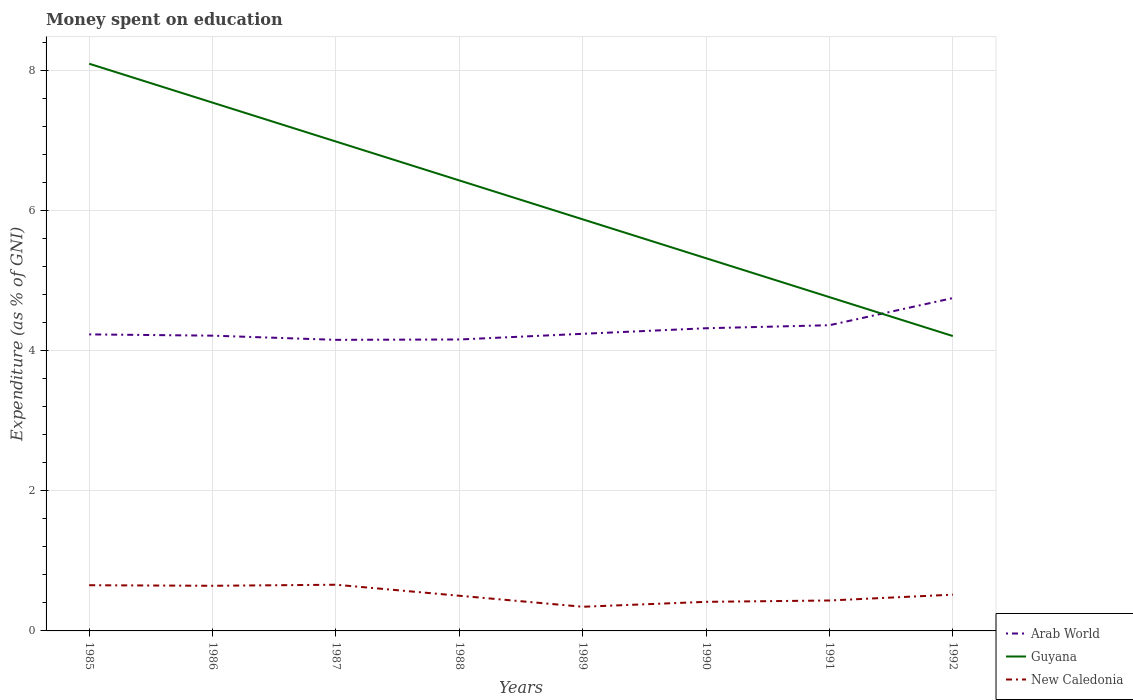How many different coloured lines are there?
Make the answer very short. 3. Is the number of lines equal to the number of legend labels?
Provide a succinct answer. Yes. Across all years, what is the maximum amount of money spent on education in New Caledonia?
Your answer should be compact. 0.35. What is the total amount of money spent on education in Arab World in the graph?
Make the answer very short. -0.08. What is the difference between the highest and the second highest amount of money spent on education in Arab World?
Your answer should be compact. 0.6. How many lines are there?
Your answer should be compact. 3. What is the difference between two consecutive major ticks on the Y-axis?
Your response must be concise. 2. How many legend labels are there?
Keep it short and to the point. 3. What is the title of the graph?
Keep it short and to the point. Money spent on education. What is the label or title of the Y-axis?
Your response must be concise. Expenditure (as % of GNI). What is the Expenditure (as % of GNI) in Arab World in 1985?
Your response must be concise. 4.23. What is the Expenditure (as % of GNI) of New Caledonia in 1985?
Offer a very short reply. 0.65. What is the Expenditure (as % of GNI) in Arab World in 1986?
Provide a short and direct response. 4.22. What is the Expenditure (as % of GNI) of Guyana in 1986?
Make the answer very short. 7.54. What is the Expenditure (as % of GNI) of New Caledonia in 1986?
Give a very brief answer. 0.64. What is the Expenditure (as % of GNI) of Arab World in 1987?
Offer a very short reply. 4.16. What is the Expenditure (as % of GNI) in Guyana in 1987?
Give a very brief answer. 6.99. What is the Expenditure (as % of GNI) of New Caledonia in 1987?
Give a very brief answer. 0.66. What is the Expenditure (as % of GNI) in Arab World in 1988?
Give a very brief answer. 4.16. What is the Expenditure (as % of GNI) in Guyana in 1988?
Offer a terse response. 6.43. What is the Expenditure (as % of GNI) of New Caledonia in 1988?
Provide a succinct answer. 0.5. What is the Expenditure (as % of GNI) of Arab World in 1989?
Provide a short and direct response. 4.24. What is the Expenditure (as % of GNI) in Guyana in 1989?
Keep it short and to the point. 5.88. What is the Expenditure (as % of GNI) of New Caledonia in 1989?
Give a very brief answer. 0.35. What is the Expenditure (as % of GNI) in Arab World in 1990?
Provide a short and direct response. 4.32. What is the Expenditure (as % of GNI) in Guyana in 1990?
Your answer should be compact. 5.32. What is the Expenditure (as % of GNI) in New Caledonia in 1990?
Provide a short and direct response. 0.42. What is the Expenditure (as % of GNI) of Arab World in 1991?
Keep it short and to the point. 4.37. What is the Expenditure (as % of GNI) in Guyana in 1991?
Your answer should be compact. 4.77. What is the Expenditure (as % of GNI) in New Caledonia in 1991?
Make the answer very short. 0.43. What is the Expenditure (as % of GNI) in Arab World in 1992?
Keep it short and to the point. 4.75. What is the Expenditure (as % of GNI) of Guyana in 1992?
Offer a terse response. 4.21. What is the Expenditure (as % of GNI) in New Caledonia in 1992?
Provide a succinct answer. 0.52. Across all years, what is the maximum Expenditure (as % of GNI) of Arab World?
Provide a short and direct response. 4.75. Across all years, what is the maximum Expenditure (as % of GNI) in Guyana?
Offer a very short reply. 8.1. Across all years, what is the maximum Expenditure (as % of GNI) of New Caledonia?
Provide a succinct answer. 0.66. Across all years, what is the minimum Expenditure (as % of GNI) of Arab World?
Make the answer very short. 4.16. Across all years, what is the minimum Expenditure (as % of GNI) in Guyana?
Your answer should be very brief. 4.21. Across all years, what is the minimum Expenditure (as % of GNI) in New Caledonia?
Keep it short and to the point. 0.35. What is the total Expenditure (as % of GNI) in Arab World in the graph?
Provide a short and direct response. 34.45. What is the total Expenditure (as % of GNI) of Guyana in the graph?
Your answer should be compact. 49.24. What is the total Expenditure (as % of GNI) of New Caledonia in the graph?
Provide a short and direct response. 4.17. What is the difference between the Expenditure (as % of GNI) of Arab World in 1985 and that in 1986?
Your response must be concise. 0.02. What is the difference between the Expenditure (as % of GNI) in Guyana in 1985 and that in 1986?
Provide a succinct answer. 0.56. What is the difference between the Expenditure (as % of GNI) of New Caledonia in 1985 and that in 1986?
Provide a short and direct response. 0.01. What is the difference between the Expenditure (as % of GNI) in Arab World in 1985 and that in 1987?
Your answer should be compact. 0.08. What is the difference between the Expenditure (as % of GNI) in New Caledonia in 1985 and that in 1987?
Provide a succinct answer. -0.01. What is the difference between the Expenditure (as % of GNI) in Arab World in 1985 and that in 1988?
Offer a very short reply. 0.07. What is the difference between the Expenditure (as % of GNI) in Guyana in 1985 and that in 1988?
Give a very brief answer. 1.67. What is the difference between the Expenditure (as % of GNI) in New Caledonia in 1985 and that in 1988?
Your answer should be compact. 0.15. What is the difference between the Expenditure (as % of GNI) in Arab World in 1985 and that in 1989?
Your response must be concise. -0.01. What is the difference between the Expenditure (as % of GNI) in Guyana in 1985 and that in 1989?
Offer a terse response. 2.22. What is the difference between the Expenditure (as % of GNI) of New Caledonia in 1985 and that in 1989?
Offer a very short reply. 0.31. What is the difference between the Expenditure (as % of GNI) in Arab World in 1985 and that in 1990?
Keep it short and to the point. -0.09. What is the difference between the Expenditure (as % of GNI) in Guyana in 1985 and that in 1990?
Your answer should be compact. 2.78. What is the difference between the Expenditure (as % of GNI) in New Caledonia in 1985 and that in 1990?
Provide a succinct answer. 0.24. What is the difference between the Expenditure (as % of GNI) in Arab World in 1985 and that in 1991?
Offer a terse response. -0.13. What is the difference between the Expenditure (as % of GNI) of Guyana in 1985 and that in 1991?
Keep it short and to the point. 3.33. What is the difference between the Expenditure (as % of GNI) of New Caledonia in 1985 and that in 1991?
Offer a terse response. 0.22. What is the difference between the Expenditure (as % of GNI) in Arab World in 1985 and that in 1992?
Your answer should be very brief. -0.52. What is the difference between the Expenditure (as % of GNI) in Guyana in 1985 and that in 1992?
Your answer should be very brief. 3.89. What is the difference between the Expenditure (as % of GNI) of New Caledonia in 1985 and that in 1992?
Provide a short and direct response. 0.13. What is the difference between the Expenditure (as % of GNI) of Arab World in 1986 and that in 1987?
Your answer should be compact. 0.06. What is the difference between the Expenditure (as % of GNI) in Guyana in 1986 and that in 1987?
Your response must be concise. 0.56. What is the difference between the Expenditure (as % of GNI) in New Caledonia in 1986 and that in 1987?
Offer a terse response. -0.01. What is the difference between the Expenditure (as % of GNI) in Arab World in 1986 and that in 1988?
Offer a very short reply. 0.05. What is the difference between the Expenditure (as % of GNI) in Guyana in 1986 and that in 1988?
Keep it short and to the point. 1.11. What is the difference between the Expenditure (as % of GNI) of New Caledonia in 1986 and that in 1988?
Give a very brief answer. 0.14. What is the difference between the Expenditure (as % of GNI) in Arab World in 1986 and that in 1989?
Keep it short and to the point. -0.03. What is the difference between the Expenditure (as % of GNI) of New Caledonia in 1986 and that in 1989?
Ensure brevity in your answer.  0.3. What is the difference between the Expenditure (as % of GNI) of Arab World in 1986 and that in 1990?
Make the answer very short. -0.11. What is the difference between the Expenditure (as % of GNI) of Guyana in 1986 and that in 1990?
Your answer should be very brief. 2.22. What is the difference between the Expenditure (as % of GNI) in New Caledonia in 1986 and that in 1990?
Your response must be concise. 0.23. What is the difference between the Expenditure (as % of GNI) in Arab World in 1986 and that in 1991?
Make the answer very short. -0.15. What is the difference between the Expenditure (as % of GNI) in Guyana in 1986 and that in 1991?
Offer a very short reply. 2.78. What is the difference between the Expenditure (as % of GNI) in New Caledonia in 1986 and that in 1991?
Provide a succinct answer. 0.21. What is the difference between the Expenditure (as % of GNI) in Arab World in 1986 and that in 1992?
Provide a succinct answer. -0.54. What is the difference between the Expenditure (as % of GNI) of New Caledonia in 1986 and that in 1992?
Provide a succinct answer. 0.13. What is the difference between the Expenditure (as % of GNI) of Arab World in 1987 and that in 1988?
Provide a short and direct response. -0.01. What is the difference between the Expenditure (as % of GNI) in Guyana in 1987 and that in 1988?
Offer a very short reply. 0.56. What is the difference between the Expenditure (as % of GNI) in New Caledonia in 1987 and that in 1988?
Keep it short and to the point. 0.16. What is the difference between the Expenditure (as % of GNI) of Arab World in 1987 and that in 1989?
Offer a very short reply. -0.09. What is the difference between the Expenditure (as % of GNI) of Guyana in 1987 and that in 1989?
Keep it short and to the point. 1.11. What is the difference between the Expenditure (as % of GNI) in New Caledonia in 1987 and that in 1989?
Make the answer very short. 0.31. What is the difference between the Expenditure (as % of GNI) in Arab World in 1987 and that in 1990?
Ensure brevity in your answer.  -0.17. What is the difference between the Expenditure (as % of GNI) of New Caledonia in 1987 and that in 1990?
Make the answer very short. 0.24. What is the difference between the Expenditure (as % of GNI) of Arab World in 1987 and that in 1991?
Your response must be concise. -0.21. What is the difference between the Expenditure (as % of GNI) in Guyana in 1987 and that in 1991?
Give a very brief answer. 2.22. What is the difference between the Expenditure (as % of GNI) of New Caledonia in 1987 and that in 1991?
Your response must be concise. 0.23. What is the difference between the Expenditure (as % of GNI) in Arab World in 1987 and that in 1992?
Keep it short and to the point. -0.6. What is the difference between the Expenditure (as % of GNI) in Guyana in 1987 and that in 1992?
Ensure brevity in your answer.  2.78. What is the difference between the Expenditure (as % of GNI) of New Caledonia in 1987 and that in 1992?
Your response must be concise. 0.14. What is the difference between the Expenditure (as % of GNI) of Arab World in 1988 and that in 1989?
Offer a very short reply. -0.08. What is the difference between the Expenditure (as % of GNI) of Guyana in 1988 and that in 1989?
Give a very brief answer. 0.56. What is the difference between the Expenditure (as % of GNI) of New Caledonia in 1988 and that in 1989?
Your response must be concise. 0.16. What is the difference between the Expenditure (as % of GNI) in Arab World in 1988 and that in 1990?
Offer a terse response. -0.16. What is the difference between the Expenditure (as % of GNI) of New Caledonia in 1988 and that in 1990?
Offer a very short reply. 0.09. What is the difference between the Expenditure (as % of GNI) in Arab World in 1988 and that in 1991?
Your answer should be compact. -0.2. What is the difference between the Expenditure (as % of GNI) of Guyana in 1988 and that in 1991?
Make the answer very short. 1.67. What is the difference between the Expenditure (as % of GNI) of New Caledonia in 1988 and that in 1991?
Your response must be concise. 0.07. What is the difference between the Expenditure (as % of GNI) in Arab World in 1988 and that in 1992?
Provide a short and direct response. -0.59. What is the difference between the Expenditure (as % of GNI) of Guyana in 1988 and that in 1992?
Your response must be concise. 2.22. What is the difference between the Expenditure (as % of GNI) of New Caledonia in 1988 and that in 1992?
Provide a short and direct response. -0.02. What is the difference between the Expenditure (as % of GNI) of Arab World in 1989 and that in 1990?
Offer a very short reply. -0.08. What is the difference between the Expenditure (as % of GNI) of Guyana in 1989 and that in 1990?
Provide a succinct answer. 0.56. What is the difference between the Expenditure (as % of GNI) in New Caledonia in 1989 and that in 1990?
Ensure brevity in your answer.  -0.07. What is the difference between the Expenditure (as % of GNI) of Arab World in 1989 and that in 1991?
Your response must be concise. -0.12. What is the difference between the Expenditure (as % of GNI) of Guyana in 1989 and that in 1991?
Make the answer very short. 1.11. What is the difference between the Expenditure (as % of GNI) in New Caledonia in 1989 and that in 1991?
Provide a succinct answer. -0.09. What is the difference between the Expenditure (as % of GNI) in Arab World in 1989 and that in 1992?
Make the answer very short. -0.51. What is the difference between the Expenditure (as % of GNI) of New Caledonia in 1989 and that in 1992?
Your response must be concise. -0.17. What is the difference between the Expenditure (as % of GNI) in Arab World in 1990 and that in 1991?
Offer a very short reply. -0.04. What is the difference between the Expenditure (as % of GNI) of Guyana in 1990 and that in 1991?
Offer a very short reply. 0.56. What is the difference between the Expenditure (as % of GNI) of New Caledonia in 1990 and that in 1991?
Your response must be concise. -0.02. What is the difference between the Expenditure (as % of GNI) of Arab World in 1990 and that in 1992?
Give a very brief answer. -0.43. What is the difference between the Expenditure (as % of GNI) in Guyana in 1990 and that in 1992?
Your answer should be very brief. 1.11. What is the difference between the Expenditure (as % of GNI) in New Caledonia in 1990 and that in 1992?
Keep it short and to the point. -0.1. What is the difference between the Expenditure (as % of GNI) of Arab World in 1991 and that in 1992?
Give a very brief answer. -0.39. What is the difference between the Expenditure (as % of GNI) in Guyana in 1991 and that in 1992?
Ensure brevity in your answer.  0.56. What is the difference between the Expenditure (as % of GNI) in New Caledonia in 1991 and that in 1992?
Keep it short and to the point. -0.08. What is the difference between the Expenditure (as % of GNI) in Arab World in 1985 and the Expenditure (as % of GNI) in Guyana in 1986?
Give a very brief answer. -3.31. What is the difference between the Expenditure (as % of GNI) in Arab World in 1985 and the Expenditure (as % of GNI) in New Caledonia in 1986?
Offer a very short reply. 3.59. What is the difference between the Expenditure (as % of GNI) in Guyana in 1985 and the Expenditure (as % of GNI) in New Caledonia in 1986?
Provide a short and direct response. 7.46. What is the difference between the Expenditure (as % of GNI) of Arab World in 1985 and the Expenditure (as % of GNI) of Guyana in 1987?
Give a very brief answer. -2.75. What is the difference between the Expenditure (as % of GNI) of Arab World in 1985 and the Expenditure (as % of GNI) of New Caledonia in 1987?
Give a very brief answer. 3.58. What is the difference between the Expenditure (as % of GNI) of Guyana in 1985 and the Expenditure (as % of GNI) of New Caledonia in 1987?
Offer a very short reply. 7.44. What is the difference between the Expenditure (as % of GNI) in Arab World in 1985 and the Expenditure (as % of GNI) in Guyana in 1988?
Offer a very short reply. -2.2. What is the difference between the Expenditure (as % of GNI) in Arab World in 1985 and the Expenditure (as % of GNI) in New Caledonia in 1988?
Make the answer very short. 3.73. What is the difference between the Expenditure (as % of GNI) in Guyana in 1985 and the Expenditure (as % of GNI) in New Caledonia in 1988?
Keep it short and to the point. 7.6. What is the difference between the Expenditure (as % of GNI) of Arab World in 1985 and the Expenditure (as % of GNI) of Guyana in 1989?
Keep it short and to the point. -1.64. What is the difference between the Expenditure (as % of GNI) of Arab World in 1985 and the Expenditure (as % of GNI) of New Caledonia in 1989?
Offer a terse response. 3.89. What is the difference between the Expenditure (as % of GNI) of Guyana in 1985 and the Expenditure (as % of GNI) of New Caledonia in 1989?
Provide a short and direct response. 7.75. What is the difference between the Expenditure (as % of GNI) of Arab World in 1985 and the Expenditure (as % of GNI) of Guyana in 1990?
Make the answer very short. -1.09. What is the difference between the Expenditure (as % of GNI) of Arab World in 1985 and the Expenditure (as % of GNI) of New Caledonia in 1990?
Make the answer very short. 3.82. What is the difference between the Expenditure (as % of GNI) in Guyana in 1985 and the Expenditure (as % of GNI) in New Caledonia in 1990?
Your response must be concise. 7.68. What is the difference between the Expenditure (as % of GNI) of Arab World in 1985 and the Expenditure (as % of GNI) of Guyana in 1991?
Your answer should be very brief. -0.53. What is the difference between the Expenditure (as % of GNI) of Arab World in 1985 and the Expenditure (as % of GNI) of New Caledonia in 1991?
Ensure brevity in your answer.  3.8. What is the difference between the Expenditure (as % of GNI) of Guyana in 1985 and the Expenditure (as % of GNI) of New Caledonia in 1991?
Provide a short and direct response. 7.67. What is the difference between the Expenditure (as % of GNI) in Arab World in 1985 and the Expenditure (as % of GNI) in Guyana in 1992?
Provide a succinct answer. 0.02. What is the difference between the Expenditure (as % of GNI) in Arab World in 1985 and the Expenditure (as % of GNI) in New Caledonia in 1992?
Provide a short and direct response. 3.72. What is the difference between the Expenditure (as % of GNI) of Guyana in 1985 and the Expenditure (as % of GNI) of New Caledonia in 1992?
Your answer should be compact. 7.58. What is the difference between the Expenditure (as % of GNI) of Arab World in 1986 and the Expenditure (as % of GNI) of Guyana in 1987?
Your answer should be very brief. -2.77. What is the difference between the Expenditure (as % of GNI) in Arab World in 1986 and the Expenditure (as % of GNI) in New Caledonia in 1987?
Provide a short and direct response. 3.56. What is the difference between the Expenditure (as % of GNI) in Guyana in 1986 and the Expenditure (as % of GNI) in New Caledonia in 1987?
Provide a succinct answer. 6.88. What is the difference between the Expenditure (as % of GNI) of Arab World in 1986 and the Expenditure (as % of GNI) of Guyana in 1988?
Offer a terse response. -2.22. What is the difference between the Expenditure (as % of GNI) of Arab World in 1986 and the Expenditure (as % of GNI) of New Caledonia in 1988?
Provide a succinct answer. 3.71. What is the difference between the Expenditure (as % of GNI) in Guyana in 1986 and the Expenditure (as % of GNI) in New Caledonia in 1988?
Your answer should be very brief. 7.04. What is the difference between the Expenditure (as % of GNI) in Arab World in 1986 and the Expenditure (as % of GNI) in Guyana in 1989?
Provide a short and direct response. -1.66. What is the difference between the Expenditure (as % of GNI) of Arab World in 1986 and the Expenditure (as % of GNI) of New Caledonia in 1989?
Provide a short and direct response. 3.87. What is the difference between the Expenditure (as % of GNI) of Guyana in 1986 and the Expenditure (as % of GNI) of New Caledonia in 1989?
Keep it short and to the point. 7.2. What is the difference between the Expenditure (as % of GNI) of Arab World in 1986 and the Expenditure (as % of GNI) of Guyana in 1990?
Make the answer very short. -1.11. What is the difference between the Expenditure (as % of GNI) in Arab World in 1986 and the Expenditure (as % of GNI) in New Caledonia in 1990?
Your answer should be compact. 3.8. What is the difference between the Expenditure (as % of GNI) in Guyana in 1986 and the Expenditure (as % of GNI) in New Caledonia in 1990?
Your answer should be very brief. 7.13. What is the difference between the Expenditure (as % of GNI) in Arab World in 1986 and the Expenditure (as % of GNI) in Guyana in 1991?
Offer a terse response. -0.55. What is the difference between the Expenditure (as % of GNI) of Arab World in 1986 and the Expenditure (as % of GNI) of New Caledonia in 1991?
Offer a terse response. 3.78. What is the difference between the Expenditure (as % of GNI) of Guyana in 1986 and the Expenditure (as % of GNI) of New Caledonia in 1991?
Your response must be concise. 7.11. What is the difference between the Expenditure (as % of GNI) in Arab World in 1986 and the Expenditure (as % of GNI) in Guyana in 1992?
Provide a short and direct response. 0.01. What is the difference between the Expenditure (as % of GNI) in Arab World in 1986 and the Expenditure (as % of GNI) in New Caledonia in 1992?
Provide a short and direct response. 3.7. What is the difference between the Expenditure (as % of GNI) of Guyana in 1986 and the Expenditure (as % of GNI) of New Caledonia in 1992?
Keep it short and to the point. 7.03. What is the difference between the Expenditure (as % of GNI) of Arab World in 1987 and the Expenditure (as % of GNI) of Guyana in 1988?
Keep it short and to the point. -2.28. What is the difference between the Expenditure (as % of GNI) in Arab World in 1987 and the Expenditure (as % of GNI) in New Caledonia in 1988?
Offer a terse response. 3.65. What is the difference between the Expenditure (as % of GNI) in Guyana in 1987 and the Expenditure (as % of GNI) in New Caledonia in 1988?
Your response must be concise. 6.49. What is the difference between the Expenditure (as % of GNI) in Arab World in 1987 and the Expenditure (as % of GNI) in Guyana in 1989?
Provide a succinct answer. -1.72. What is the difference between the Expenditure (as % of GNI) of Arab World in 1987 and the Expenditure (as % of GNI) of New Caledonia in 1989?
Ensure brevity in your answer.  3.81. What is the difference between the Expenditure (as % of GNI) in Guyana in 1987 and the Expenditure (as % of GNI) in New Caledonia in 1989?
Your response must be concise. 6.64. What is the difference between the Expenditure (as % of GNI) in Arab World in 1987 and the Expenditure (as % of GNI) in Guyana in 1990?
Give a very brief answer. -1.17. What is the difference between the Expenditure (as % of GNI) in Arab World in 1987 and the Expenditure (as % of GNI) in New Caledonia in 1990?
Your answer should be compact. 3.74. What is the difference between the Expenditure (as % of GNI) in Guyana in 1987 and the Expenditure (as % of GNI) in New Caledonia in 1990?
Your answer should be very brief. 6.57. What is the difference between the Expenditure (as % of GNI) in Arab World in 1987 and the Expenditure (as % of GNI) in Guyana in 1991?
Offer a terse response. -0.61. What is the difference between the Expenditure (as % of GNI) in Arab World in 1987 and the Expenditure (as % of GNI) in New Caledonia in 1991?
Your answer should be very brief. 3.72. What is the difference between the Expenditure (as % of GNI) in Guyana in 1987 and the Expenditure (as % of GNI) in New Caledonia in 1991?
Your answer should be compact. 6.55. What is the difference between the Expenditure (as % of GNI) of Arab World in 1987 and the Expenditure (as % of GNI) of Guyana in 1992?
Your answer should be compact. -0.05. What is the difference between the Expenditure (as % of GNI) of Arab World in 1987 and the Expenditure (as % of GNI) of New Caledonia in 1992?
Provide a succinct answer. 3.64. What is the difference between the Expenditure (as % of GNI) in Guyana in 1987 and the Expenditure (as % of GNI) in New Caledonia in 1992?
Provide a short and direct response. 6.47. What is the difference between the Expenditure (as % of GNI) in Arab World in 1988 and the Expenditure (as % of GNI) in Guyana in 1989?
Offer a very short reply. -1.72. What is the difference between the Expenditure (as % of GNI) in Arab World in 1988 and the Expenditure (as % of GNI) in New Caledonia in 1989?
Offer a very short reply. 3.82. What is the difference between the Expenditure (as % of GNI) of Guyana in 1988 and the Expenditure (as % of GNI) of New Caledonia in 1989?
Your answer should be compact. 6.09. What is the difference between the Expenditure (as % of GNI) in Arab World in 1988 and the Expenditure (as % of GNI) in Guyana in 1990?
Offer a terse response. -1.16. What is the difference between the Expenditure (as % of GNI) in Arab World in 1988 and the Expenditure (as % of GNI) in New Caledonia in 1990?
Your answer should be compact. 3.75. What is the difference between the Expenditure (as % of GNI) of Guyana in 1988 and the Expenditure (as % of GNI) of New Caledonia in 1990?
Make the answer very short. 6.02. What is the difference between the Expenditure (as % of GNI) of Arab World in 1988 and the Expenditure (as % of GNI) of Guyana in 1991?
Offer a very short reply. -0.6. What is the difference between the Expenditure (as % of GNI) in Arab World in 1988 and the Expenditure (as % of GNI) in New Caledonia in 1991?
Provide a succinct answer. 3.73. What is the difference between the Expenditure (as % of GNI) of Guyana in 1988 and the Expenditure (as % of GNI) of New Caledonia in 1991?
Offer a very short reply. 6. What is the difference between the Expenditure (as % of GNI) in Arab World in 1988 and the Expenditure (as % of GNI) in Guyana in 1992?
Provide a succinct answer. -0.05. What is the difference between the Expenditure (as % of GNI) in Arab World in 1988 and the Expenditure (as % of GNI) in New Caledonia in 1992?
Ensure brevity in your answer.  3.64. What is the difference between the Expenditure (as % of GNI) of Guyana in 1988 and the Expenditure (as % of GNI) of New Caledonia in 1992?
Your answer should be very brief. 5.92. What is the difference between the Expenditure (as % of GNI) in Arab World in 1989 and the Expenditure (as % of GNI) in Guyana in 1990?
Ensure brevity in your answer.  -1.08. What is the difference between the Expenditure (as % of GNI) of Arab World in 1989 and the Expenditure (as % of GNI) of New Caledonia in 1990?
Keep it short and to the point. 3.83. What is the difference between the Expenditure (as % of GNI) of Guyana in 1989 and the Expenditure (as % of GNI) of New Caledonia in 1990?
Provide a short and direct response. 5.46. What is the difference between the Expenditure (as % of GNI) in Arab World in 1989 and the Expenditure (as % of GNI) in Guyana in 1991?
Keep it short and to the point. -0.52. What is the difference between the Expenditure (as % of GNI) of Arab World in 1989 and the Expenditure (as % of GNI) of New Caledonia in 1991?
Your answer should be compact. 3.81. What is the difference between the Expenditure (as % of GNI) of Guyana in 1989 and the Expenditure (as % of GNI) of New Caledonia in 1991?
Your response must be concise. 5.44. What is the difference between the Expenditure (as % of GNI) in Arab World in 1989 and the Expenditure (as % of GNI) in Guyana in 1992?
Make the answer very short. 0.03. What is the difference between the Expenditure (as % of GNI) of Arab World in 1989 and the Expenditure (as % of GNI) of New Caledonia in 1992?
Make the answer very short. 3.73. What is the difference between the Expenditure (as % of GNI) of Guyana in 1989 and the Expenditure (as % of GNI) of New Caledonia in 1992?
Your response must be concise. 5.36. What is the difference between the Expenditure (as % of GNI) of Arab World in 1990 and the Expenditure (as % of GNI) of Guyana in 1991?
Provide a succinct answer. -0.44. What is the difference between the Expenditure (as % of GNI) of Arab World in 1990 and the Expenditure (as % of GNI) of New Caledonia in 1991?
Your response must be concise. 3.89. What is the difference between the Expenditure (as % of GNI) of Guyana in 1990 and the Expenditure (as % of GNI) of New Caledonia in 1991?
Offer a very short reply. 4.89. What is the difference between the Expenditure (as % of GNI) in Arab World in 1990 and the Expenditure (as % of GNI) in Guyana in 1992?
Offer a very short reply. 0.11. What is the difference between the Expenditure (as % of GNI) in Arab World in 1990 and the Expenditure (as % of GNI) in New Caledonia in 1992?
Your answer should be very brief. 3.8. What is the difference between the Expenditure (as % of GNI) in Guyana in 1990 and the Expenditure (as % of GNI) in New Caledonia in 1992?
Your answer should be compact. 4.8. What is the difference between the Expenditure (as % of GNI) of Arab World in 1991 and the Expenditure (as % of GNI) of Guyana in 1992?
Provide a short and direct response. 0.15. What is the difference between the Expenditure (as % of GNI) in Arab World in 1991 and the Expenditure (as % of GNI) in New Caledonia in 1992?
Ensure brevity in your answer.  3.85. What is the difference between the Expenditure (as % of GNI) of Guyana in 1991 and the Expenditure (as % of GNI) of New Caledonia in 1992?
Offer a very short reply. 4.25. What is the average Expenditure (as % of GNI) of Arab World per year?
Provide a succinct answer. 4.31. What is the average Expenditure (as % of GNI) of Guyana per year?
Give a very brief answer. 6.16. What is the average Expenditure (as % of GNI) in New Caledonia per year?
Make the answer very short. 0.52. In the year 1985, what is the difference between the Expenditure (as % of GNI) of Arab World and Expenditure (as % of GNI) of Guyana?
Provide a succinct answer. -3.87. In the year 1985, what is the difference between the Expenditure (as % of GNI) of Arab World and Expenditure (as % of GNI) of New Caledonia?
Offer a terse response. 3.58. In the year 1985, what is the difference between the Expenditure (as % of GNI) in Guyana and Expenditure (as % of GNI) in New Caledonia?
Provide a short and direct response. 7.45. In the year 1986, what is the difference between the Expenditure (as % of GNI) in Arab World and Expenditure (as % of GNI) in Guyana?
Give a very brief answer. -3.33. In the year 1986, what is the difference between the Expenditure (as % of GNI) in Arab World and Expenditure (as % of GNI) in New Caledonia?
Ensure brevity in your answer.  3.57. In the year 1986, what is the difference between the Expenditure (as % of GNI) of Guyana and Expenditure (as % of GNI) of New Caledonia?
Ensure brevity in your answer.  6.9. In the year 1987, what is the difference between the Expenditure (as % of GNI) of Arab World and Expenditure (as % of GNI) of Guyana?
Offer a terse response. -2.83. In the year 1987, what is the difference between the Expenditure (as % of GNI) in Arab World and Expenditure (as % of GNI) in New Caledonia?
Ensure brevity in your answer.  3.5. In the year 1987, what is the difference between the Expenditure (as % of GNI) of Guyana and Expenditure (as % of GNI) of New Caledonia?
Ensure brevity in your answer.  6.33. In the year 1988, what is the difference between the Expenditure (as % of GNI) in Arab World and Expenditure (as % of GNI) in Guyana?
Give a very brief answer. -2.27. In the year 1988, what is the difference between the Expenditure (as % of GNI) of Arab World and Expenditure (as % of GNI) of New Caledonia?
Keep it short and to the point. 3.66. In the year 1988, what is the difference between the Expenditure (as % of GNI) in Guyana and Expenditure (as % of GNI) in New Caledonia?
Offer a terse response. 5.93. In the year 1989, what is the difference between the Expenditure (as % of GNI) in Arab World and Expenditure (as % of GNI) in Guyana?
Offer a very short reply. -1.63. In the year 1989, what is the difference between the Expenditure (as % of GNI) of Arab World and Expenditure (as % of GNI) of New Caledonia?
Provide a succinct answer. 3.9. In the year 1989, what is the difference between the Expenditure (as % of GNI) of Guyana and Expenditure (as % of GNI) of New Caledonia?
Provide a short and direct response. 5.53. In the year 1990, what is the difference between the Expenditure (as % of GNI) in Arab World and Expenditure (as % of GNI) in Guyana?
Make the answer very short. -1. In the year 1990, what is the difference between the Expenditure (as % of GNI) of Arab World and Expenditure (as % of GNI) of New Caledonia?
Provide a succinct answer. 3.91. In the year 1990, what is the difference between the Expenditure (as % of GNI) of Guyana and Expenditure (as % of GNI) of New Caledonia?
Keep it short and to the point. 4.91. In the year 1991, what is the difference between the Expenditure (as % of GNI) in Arab World and Expenditure (as % of GNI) in Guyana?
Keep it short and to the point. -0.4. In the year 1991, what is the difference between the Expenditure (as % of GNI) in Arab World and Expenditure (as % of GNI) in New Caledonia?
Ensure brevity in your answer.  3.93. In the year 1991, what is the difference between the Expenditure (as % of GNI) in Guyana and Expenditure (as % of GNI) in New Caledonia?
Keep it short and to the point. 4.33. In the year 1992, what is the difference between the Expenditure (as % of GNI) in Arab World and Expenditure (as % of GNI) in Guyana?
Provide a succinct answer. 0.54. In the year 1992, what is the difference between the Expenditure (as % of GNI) of Arab World and Expenditure (as % of GNI) of New Caledonia?
Keep it short and to the point. 4.24. In the year 1992, what is the difference between the Expenditure (as % of GNI) of Guyana and Expenditure (as % of GNI) of New Caledonia?
Make the answer very short. 3.69. What is the ratio of the Expenditure (as % of GNI) of Arab World in 1985 to that in 1986?
Offer a terse response. 1. What is the ratio of the Expenditure (as % of GNI) of Guyana in 1985 to that in 1986?
Provide a succinct answer. 1.07. What is the ratio of the Expenditure (as % of GNI) in New Caledonia in 1985 to that in 1986?
Offer a terse response. 1.01. What is the ratio of the Expenditure (as % of GNI) in Arab World in 1985 to that in 1987?
Keep it short and to the point. 1.02. What is the ratio of the Expenditure (as % of GNI) in Guyana in 1985 to that in 1987?
Make the answer very short. 1.16. What is the ratio of the Expenditure (as % of GNI) of Arab World in 1985 to that in 1988?
Keep it short and to the point. 1.02. What is the ratio of the Expenditure (as % of GNI) in Guyana in 1985 to that in 1988?
Provide a succinct answer. 1.26. What is the ratio of the Expenditure (as % of GNI) in New Caledonia in 1985 to that in 1988?
Your answer should be very brief. 1.3. What is the ratio of the Expenditure (as % of GNI) in Arab World in 1985 to that in 1989?
Your response must be concise. 1. What is the ratio of the Expenditure (as % of GNI) in Guyana in 1985 to that in 1989?
Your answer should be very brief. 1.38. What is the ratio of the Expenditure (as % of GNI) in New Caledonia in 1985 to that in 1989?
Your answer should be very brief. 1.89. What is the ratio of the Expenditure (as % of GNI) in Arab World in 1985 to that in 1990?
Offer a very short reply. 0.98. What is the ratio of the Expenditure (as % of GNI) in Guyana in 1985 to that in 1990?
Ensure brevity in your answer.  1.52. What is the ratio of the Expenditure (as % of GNI) in New Caledonia in 1985 to that in 1990?
Make the answer very short. 1.57. What is the ratio of the Expenditure (as % of GNI) of Arab World in 1985 to that in 1991?
Provide a succinct answer. 0.97. What is the ratio of the Expenditure (as % of GNI) in Guyana in 1985 to that in 1991?
Provide a succinct answer. 1.7. What is the ratio of the Expenditure (as % of GNI) of New Caledonia in 1985 to that in 1991?
Your answer should be compact. 1.5. What is the ratio of the Expenditure (as % of GNI) of Arab World in 1985 to that in 1992?
Ensure brevity in your answer.  0.89. What is the ratio of the Expenditure (as % of GNI) in Guyana in 1985 to that in 1992?
Your answer should be compact. 1.92. What is the ratio of the Expenditure (as % of GNI) in New Caledonia in 1985 to that in 1992?
Make the answer very short. 1.26. What is the ratio of the Expenditure (as % of GNI) of Arab World in 1986 to that in 1987?
Give a very brief answer. 1.01. What is the ratio of the Expenditure (as % of GNI) in Guyana in 1986 to that in 1987?
Your response must be concise. 1.08. What is the ratio of the Expenditure (as % of GNI) in New Caledonia in 1986 to that in 1987?
Your answer should be compact. 0.98. What is the ratio of the Expenditure (as % of GNI) in Arab World in 1986 to that in 1988?
Provide a succinct answer. 1.01. What is the ratio of the Expenditure (as % of GNI) of Guyana in 1986 to that in 1988?
Give a very brief answer. 1.17. What is the ratio of the Expenditure (as % of GNI) in New Caledonia in 1986 to that in 1988?
Keep it short and to the point. 1.28. What is the ratio of the Expenditure (as % of GNI) in Arab World in 1986 to that in 1989?
Provide a succinct answer. 0.99. What is the ratio of the Expenditure (as % of GNI) of Guyana in 1986 to that in 1989?
Offer a very short reply. 1.28. What is the ratio of the Expenditure (as % of GNI) in New Caledonia in 1986 to that in 1989?
Keep it short and to the point. 1.87. What is the ratio of the Expenditure (as % of GNI) of Arab World in 1986 to that in 1990?
Keep it short and to the point. 0.98. What is the ratio of the Expenditure (as % of GNI) in Guyana in 1986 to that in 1990?
Keep it short and to the point. 1.42. What is the ratio of the Expenditure (as % of GNI) of New Caledonia in 1986 to that in 1990?
Your response must be concise. 1.55. What is the ratio of the Expenditure (as % of GNI) in Arab World in 1986 to that in 1991?
Your answer should be compact. 0.97. What is the ratio of the Expenditure (as % of GNI) in Guyana in 1986 to that in 1991?
Offer a terse response. 1.58. What is the ratio of the Expenditure (as % of GNI) in New Caledonia in 1986 to that in 1991?
Ensure brevity in your answer.  1.48. What is the ratio of the Expenditure (as % of GNI) of Arab World in 1986 to that in 1992?
Ensure brevity in your answer.  0.89. What is the ratio of the Expenditure (as % of GNI) in Guyana in 1986 to that in 1992?
Provide a short and direct response. 1.79. What is the ratio of the Expenditure (as % of GNI) in New Caledonia in 1986 to that in 1992?
Your response must be concise. 1.24. What is the ratio of the Expenditure (as % of GNI) of Guyana in 1987 to that in 1988?
Your answer should be very brief. 1.09. What is the ratio of the Expenditure (as % of GNI) in New Caledonia in 1987 to that in 1988?
Ensure brevity in your answer.  1.31. What is the ratio of the Expenditure (as % of GNI) in Arab World in 1987 to that in 1989?
Keep it short and to the point. 0.98. What is the ratio of the Expenditure (as % of GNI) of Guyana in 1987 to that in 1989?
Your answer should be compact. 1.19. What is the ratio of the Expenditure (as % of GNI) in New Caledonia in 1987 to that in 1989?
Provide a short and direct response. 1.91. What is the ratio of the Expenditure (as % of GNI) of Arab World in 1987 to that in 1990?
Ensure brevity in your answer.  0.96. What is the ratio of the Expenditure (as % of GNI) of Guyana in 1987 to that in 1990?
Provide a short and direct response. 1.31. What is the ratio of the Expenditure (as % of GNI) in New Caledonia in 1987 to that in 1990?
Your response must be concise. 1.59. What is the ratio of the Expenditure (as % of GNI) of Arab World in 1987 to that in 1991?
Your response must be concise. 0.95. What is the ratio of the Expenditure (as % of GNI) of Guyana in 1987 to that in 1991?
Offer a very short reply. 1.47. What is the ratio of the Expenditure (as % of GNI) of New Caledonia in 1987 to that in 1991?
Provide a succinct answer. 1.52. What is the ratio of the Expenditure (as % of GNI) in Arab World in 1987 to that in 1992?
Provide a short and direct response. 0.87. What is the ratio of the Expenditure (as % of GNI) in Guyana in 1987 to that in 1992?
Give a very brief answer. 1.66. What is the ratio of the Expenditure (as % of GNI) of New Caledonia in 1987 to that in 1992?
Your response must be concise. 1.27. What is the ratio of the Expenditure (as % of GNI) of Arab World in 1988 to that in 1989?
Your response must be concise. 0.98. What is the ratio of the Expenditure (as % of GNI) of Guyana in 1988 to that in 1989?
Your answer should be very brief. 1.09. What is the ratio of the Expenditure (as % of GNI) in New Caledonia in 1988 to that in 1989?
Your response must be concise. 1.46. What is the ratio of the Expenditure (as % of GNI) in Arab World in 1988 to that in 1990?
Ensure brevity in your answer.  0.96. What is the ratio of the Expenditure (as % of GNI) in Guyana in 1988 to that in 1990?
Keep it short and to the point. 1.21. What is the ratio of the Expenditure (as % of GNI) in New Caledonia in 1988 to that in 1990?
Offer a terse response. 1.21. What is the ratio of the Expenditure (as % of GNI) of Arab World in 1988 to that in 1991?
Keep it short and to the point. 0.95. What is the ratio of the Expenditure (as % of GNI) of Guyana in 1988 to that in 1991?
Provide a short and direct response. 1.35. What is the ratio of the Expenditure (as % of GNI) of New Caledonia in 1988 to that in 1991?
Provide a short and direct response. 1.16. What is the ratio of the Expenditure (as % of GNI) of Arab World in 1988 to that in 1992?
Provide a short and direct response. 0.88. What is the ratio of the Expenditure (as % of GNI) in Guyana in 1988 to that in 1992?
Make the answer very short. 1.53. What is the ratio of the Expenditure (as % of GNI) of New Caledonia in 1988 to that in 1992?
Your answer should be very brief. 0.97. What is the ratio of the Expenditure (as % of GNI) in Arab World in 1989 to that in 1990?
Your response must be concise. 0.98. What is the ratio of the Expenditure (as % of GNI) in Guyana in 1989 to that in 1990?
Provide a short and direct response. 1.1. What is the ratio of the Expenditure (as % of GNI) of New Caledonia in 1989 to that in 1990?
Your response must be concise. 0.83. What is the ratio of the Expenditure (as % of GNI) of Arab World in 1989 to that in 1991?
Offer a terse response. 0.97. What is the ratio of the Expenditure (as % of GNI) of Guyana in 1989 to that in 1991?
Your answer should be compact. 1.23. What is the ratio of the Expenditure (as % of GNI) in New Caledonia in 1989 to that in 1991?
Make the answer very short. 0.79. What is the ratio of the Expenditure (as % of GNI) in Arab World in 1989 to that in 1992?
Keep it short and to the point. 0.89. What is the ratio of the Expenditure (as % of GNI) in Guyana in 1989 to that in 1992?
Your answer should be very brief. 1.4. What is the ratio of the Expenditure (as % of GNI) in New Caledonia in 1989 to that in 1992?
Make the answer very short. 0.67. What is the ratio of the Expenditure (as % of GNI) in Arab World in 1990 to that in 1991?
Offer a terse response. 0.99. What is the ratio of the Expenditure (as % of GNI) in Guyana in 1990 to that in 1991?
Make the answer very short. 1.12. What is the ratio of the Expenditure (as % of GNI) of New Caledonia in 1990 to that in 1991?
Keep it short and to the point. 0.96. What is the ratio of the Expenditure (as % of GNI) of Arab World in 1990 to that in 1992?
Keep it short and to the point. 0.91. What is the ratio of the Expenditure (as % of GNI) in Guyana in 1990 to that in 1992?
Ensure brevity in your answer.  1.26. What is the ratio of the Expenditure (as % of GNI) of New Caledonia in 1990 to that in 1992?
Keep it short and to the point. 0.8. What is the ratio of the Expenditure (as % of GNI) in Arab World in 1991 to that in 1992?
Give a very brief answer. 0.92. What is the ratio of the Expenditure (as % of GNI) of Guyana in 1991 to that in 1992?
Offer a terse response. 1.13. What is the ratio of the Expenditure (as % of GNI) of New Caledonia in 1991 to that in 1992?
Keep it short and to the point. 0.84. What is the difference between the highest and the second highest Expenditure (as % of GNI) in Arab World?
Your answer should be compact. 0.39. What is the difference between the highest and the second highest Expenditure (as % of GNI) in Guyana?
Your answer should be very brief. 0.56. What is the difference between the highest and the second highest Expenditure (as % of GNI) in New Caledonia?
Offer a terse response. 0.01. What is the difference between the highest and the lowest Expenditure (as % of GNI) of Arab World?
Provide a succinct answer. 0.6. What is the difference between the highest and the lowest Expenditure (as % of GNI) of Guyana?
Your response must be concise. 3.89. What is the difference between the highest and the lowest Expenditure (as % of GNI) of New Caledonia?
Give a very brief answer. 0.31. 